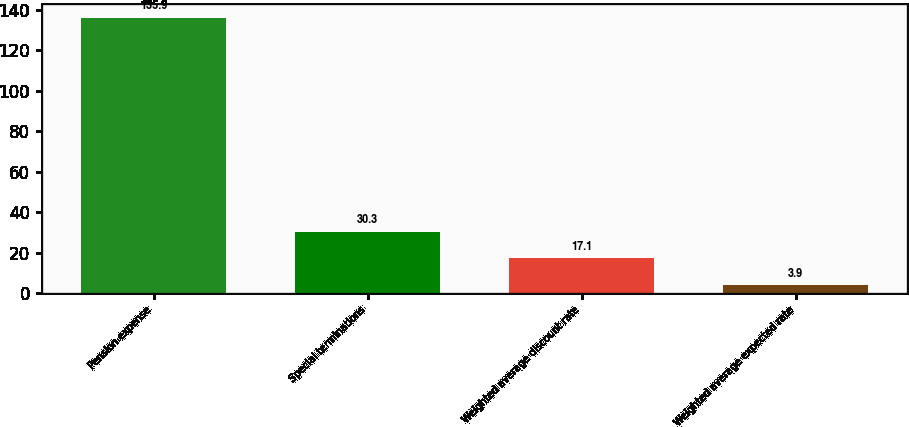Convert chart. <chart><loc_0><loc_0><loc_500><loc_500><bar_chart><fcel>Pension expense<fcel>Special terminations<fcel>Weighted average discount rate<fcel>Weighted average expected rate<nl><fcel>135.9<fcel>30.3<fcel>17.1<fcel>3.9<nl></chart> 